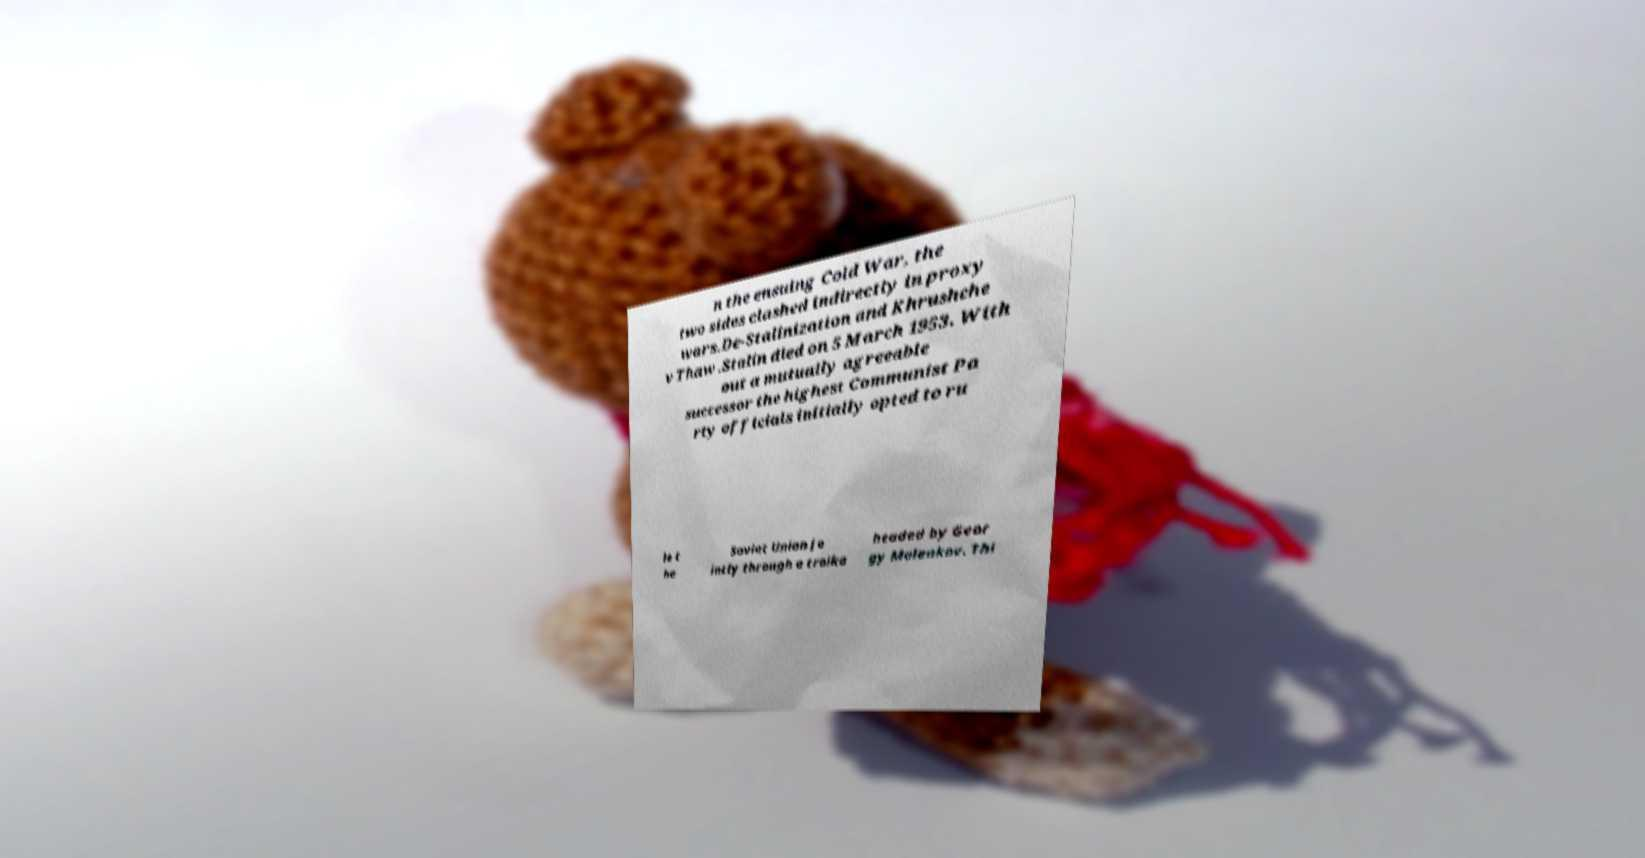There's text embedded in this image that I need extracted. Can you transcribe it verbatim? n the ensuing Cold War, the two sides clashed indirectly in proxy wars.De-Stalinization and Khrushche v Thaw .Stalin died on 5 March 1953. With out a mutually agreeable successor the highest Communist Pa rty officials initially opted to ru le t he Soviet Union jo intly through a troika headed by Geor gy Malenkov. Thi 